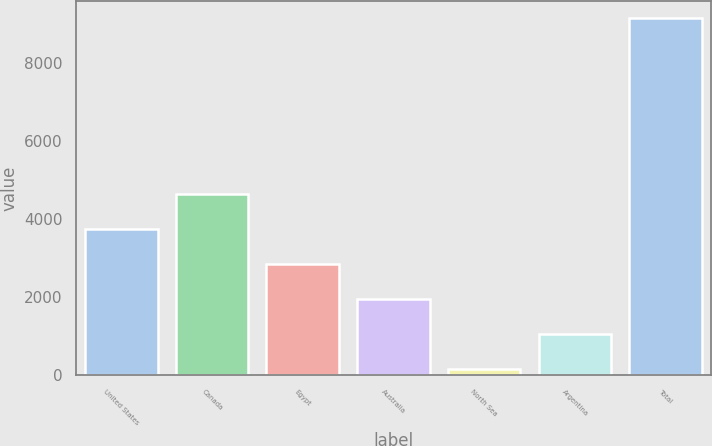Convert chart. <chart><loc_0><loc_0><loc_500><loc_500><bar_chart><fcel>United States<fcel>Canada<fcel>Egypt<fcel>Australia<fcel>North Sea<fcel>Argentina<fcel>Total<nl><fcel>3750.8<fcel>4648.5<fcel>2853.1<fcel>1955.4<fcel>160<fcel>1057.7<fcel>9137<nl></chart> 